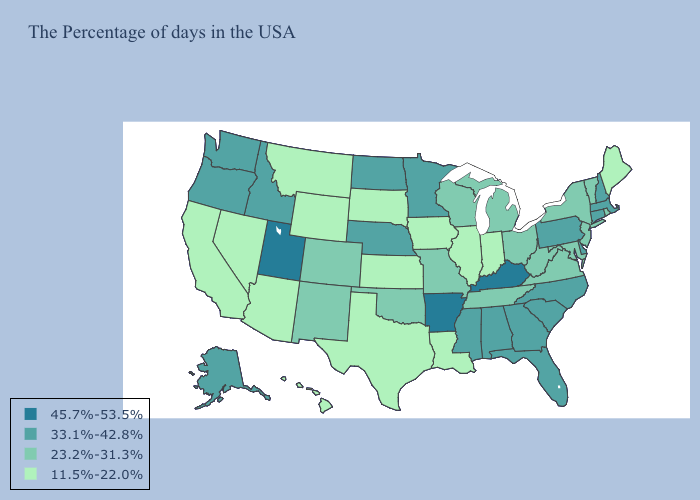Is the legend a continuous bar?
Give a very brief answer. No. Name the states that have a value in the range 33.1%-42.8%?
Write a very short answer. Massachusetts, New Hampshire, Connecticut, Delaware, Pennsylvania, North Carolina, South Carolina, Florida, Georgia, Alabama, Mississippi, Minnesota, Nebraska, North Dakota, Idaho, Washington, Oregon, Alaska. What is the value of Minnesota?
Concise answer only. 33.1%-42.8%. Which states have the highest value in the USA?
Give a very brief answer. Kentucky, Arkansas, Utah. Name the states that have a value in the range 45.7%-53.5%?
Short answer required. Kentucky, Arkansas, Utah. What is the value of New Jersey?
Short answer required. 23.2%-31.3%. What is the lowest value in the USA?
Be succinct. 11.5%-22.0%. What is the value of Colorado?
Answer briefly. 23.2%-31.3%. What is the value of Vermont?
Short answer required. 23.2%-31.3%. Which states have the highest value in the USA?
Answer briefly. Kentucky, Arkansas, Utah. How many symbols are there in the legend?
Be succinct. 4. Name the states that have a value in the range 45.7%-53.5%?
Short answer required. Kentucky, Arkansas, Utah. Which states hav the highest value in the MidWest?
Write a very short answer. Minnesota, Nebraska, North Dakota. What is the highest value in the USA?
Give a very brief answer. 45.7%-53.5%. What is the highest value in the USA?
Quick response, please. 45.7%-53.5%. 